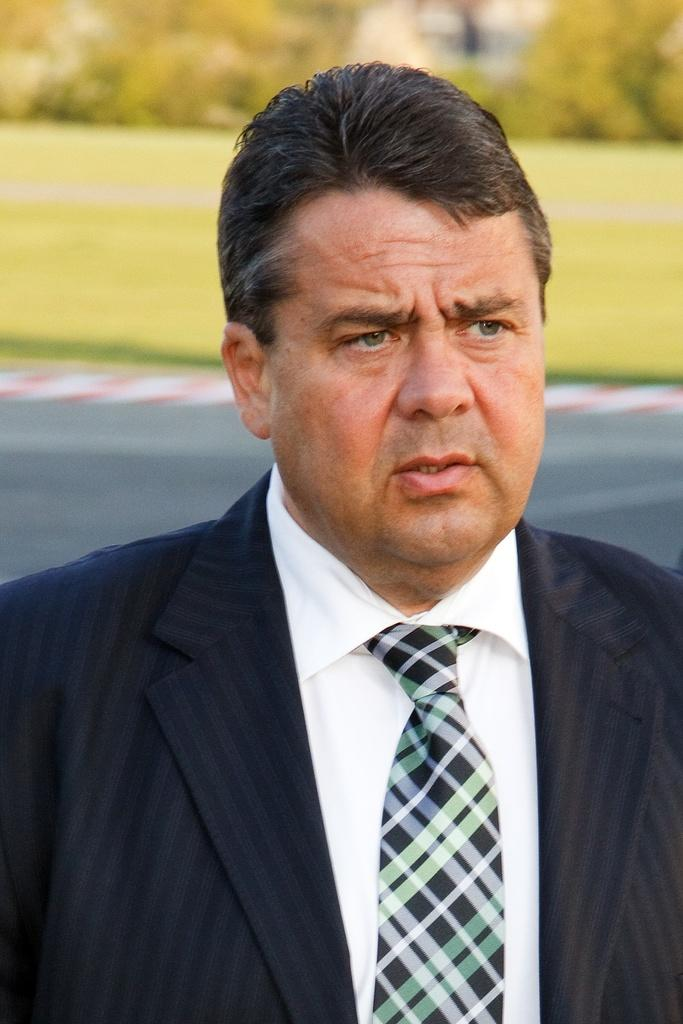What type of clothing is visible in the image? There is a blazer, a shirt, and a tie visible in the image. What can be seen in the background of the image? There is a road, ground, and many trees visible in the background of the image. What type of paper is being used to hold the tie in place in the image? There is no paper visible in the image, and the tie is not being held in place by any paper. 